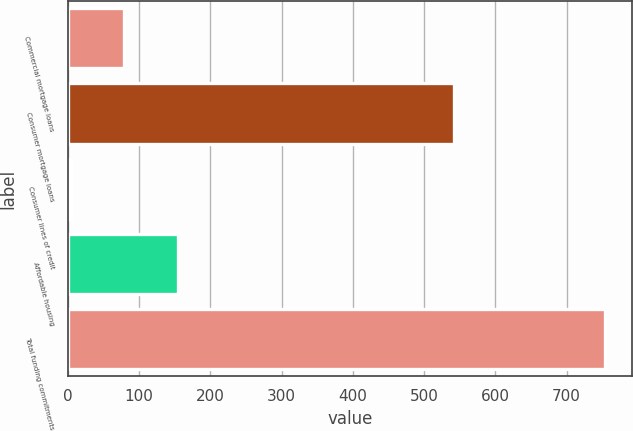Convert chart to OTSL. <chart><loc_0><loc_0><loc_500><loc_500><bar_chart><fcel>Commercial mortgage loans<fcel>Consumer mortgage loans<fcel>Consumer lines of credit<fcel>Affordable housing<fcel>Total funding commitments<nl><fcel>79<fcel>542<fcel>4<fcel>154<fcel>754<nl></chart> 